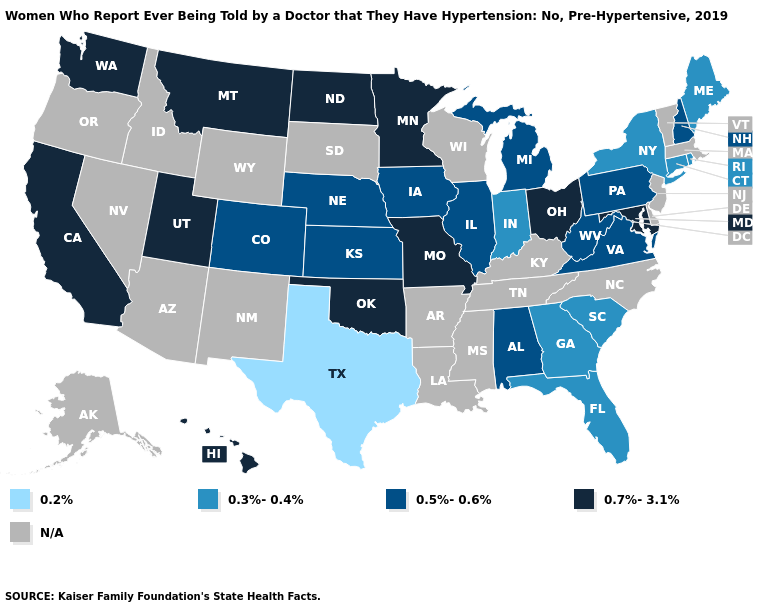Which states have the lowest value in the Northeast?
Be succinct. Connecticut, Maine, New York, Rhode Island. Does Rhode Island have the lowest value in the Northeast?
Short answer required. Yes. Among the states that border Arizona , which have the lowest value?
Give a very brief answer. Colorado. Does Texas have the lowest value in the USA?
Be succinct. Yes. Name the states that have a value in the range 0.5%-0.6%?
Concise answer only. Alabama, Colorado, Illinois, Iowa, Kansas, Michigan, Nebraska, New Hampshire, Pennsylvania, Virginia, West Virginia. Name the states that have a value in the range 0.7%-3.1%?
Be succinct. California, Hawaii, Maryland, Minnesota, Missouri, Montana, North Dakota, Ohio, Oklahoma, Utah, Washington. Name the states that have a value in the range N/A?
Concise answer only. Alaska, Arizona, Arkansas, Delaware, Idaho, Kentucky, Louisiana, Massachusetts, Mississippi, Nevada, New Jersey, New Mexico, North Carolina, Oregon, South Dakota, Tennessee, Vermont, Wisconsin, Wyoming. Does the first symbol in the legend represent the smallest category?
Short answer required. Yes. Among the states that border North Carolina , which have the lowest value?
Answer briefly. Georgia, South Carolina. Which states have the highest value in the USA?
Quick response, please. California, Hawaii, Maryland, Minnesota, Missouri, Montana, North Dakota, Ohio, Oklahoma, Utah, Washington. Name the states that have a value in the range 0.7%-3.1%?
Concise answer only. California, Hawaii, Maryland, Minnesota, Missouri, Montana, North Dakota, Ohio, Oklahoma, Utah, Washington. What is the value of Minnesota?
Concise answer only. 0.7%-3.1%. What is the highest value in the USA?
Keep it brief. 0.7%-3.1%. Which states have the lowest value in the USA?
Quick response, please. Texas. Which states have the lowest value in the South?
Answer briefly. Texas. 